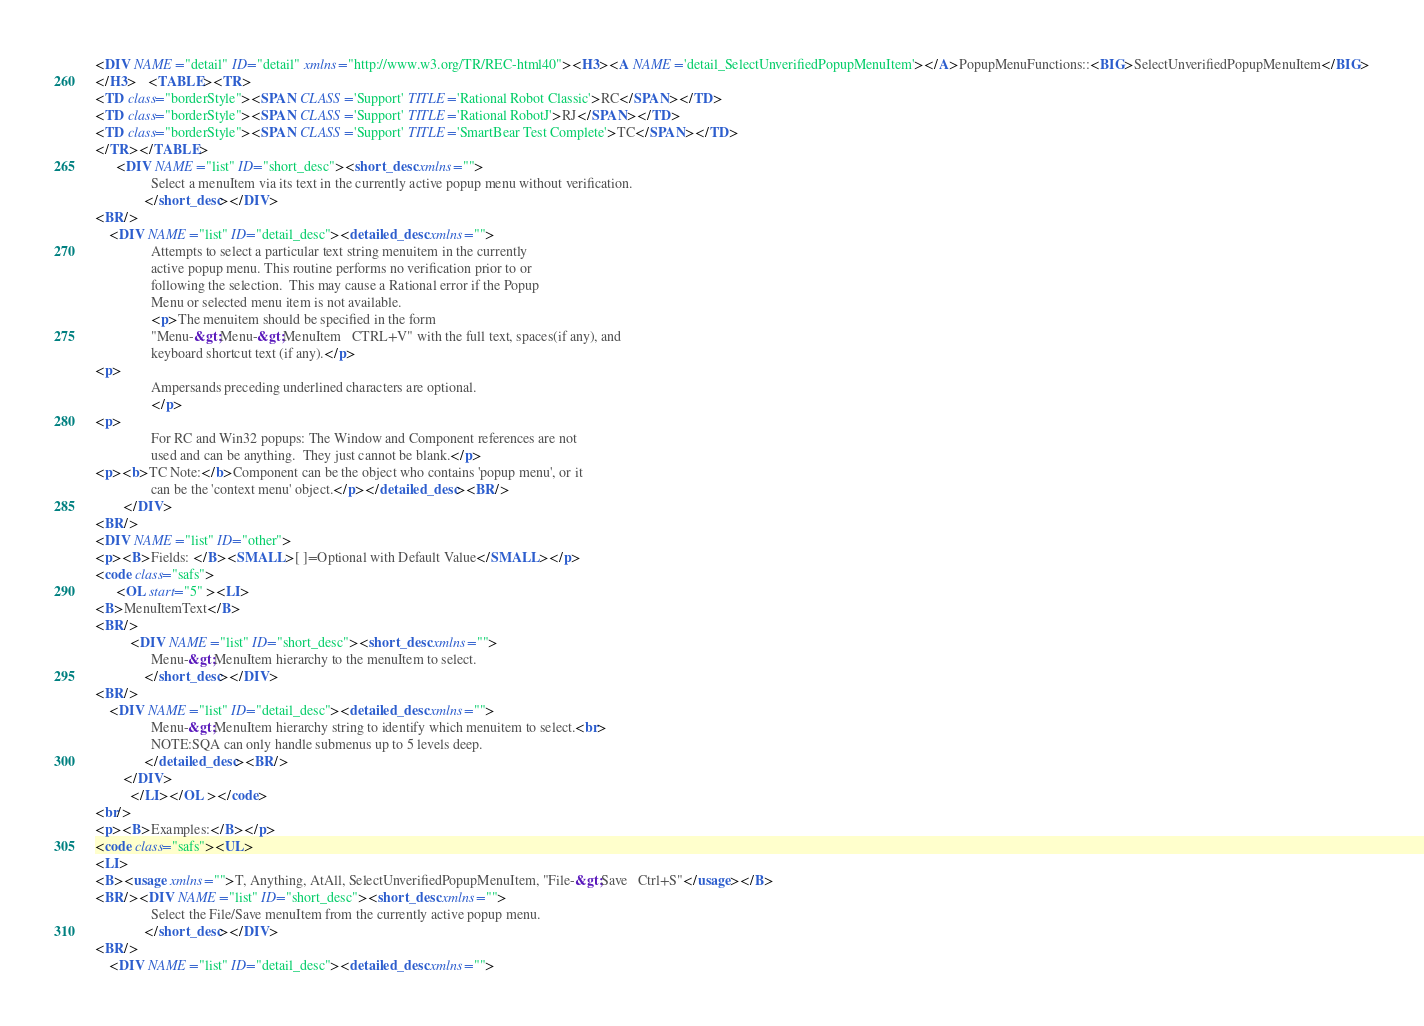<code> <loc_0><loc_0><loc_500><loc_500><_HTML_><DIV NAME="detail" ID="detail" xmlns="http://www.w3.org/TR/REC-html40"><H3><A NAME='detail_SelectUnverifiedPopupMenuItem'></A>PopupMenuFunctions::<BIG>SelectUnverifiedPopupMenuItem</BIG>
</H3>   <TABLE><TR>
<TD class="borderStyle"><SPAN CLASS='Support' TITLE='Rational Robot Classic'>RC</SPAN></TD>
<TD class="borderStyle"><SPAN CLASS='Support' TITLE='Rational RobotJ'>RJ</SPAN></TD>
<TD class="borderStyle"><SPAN CLASS='Support' TITLE='SmartBear Test Complete'>TC</SPAN></TD>
</TR></TABLE>
	  <DIV NAME="list" ID="short_desc"><short_desc xmlns=""> 
                Select a menuItem via its text in the currently active popup menu without verification.
              </short_desc></DIV>
<BR/>
	<DIV NAME="list" ID="detail_desc"><detailed_desc xmlns=""> 
                Attempts to select a particular text string menuitem in the currently 
                active popup menu. This routine performs no verification prior to or
                following the selection.  This may cause a Rational error if the Popup
                Menu or selected menu item is not available. 
                <p>The menuitem should be specified in the form 
                "Menu-&gt;Menu-&gt;MenuItem   CTRL+V" with the full text, spaces(if any), and 
                keyboard shortcut text (if any).</p>
<p>
                Ampersands preceding underlined characters are optional.
                </p>
<p>
                For RC and Win32 popups: The Window and Component references are not 
                used and can be anything.  They just cannot be blank.</p>
<p><b>TC Note:</b>Component can be the object who contains 'popup menu', or it
                can be the 'context menu' object.</p></detailed_desc><BR/>
		</DIV>
<BR/>
<DIV NAME="list" ID="other">
<p><B>Fields: </B><SMALL>[ ]=Optional with Default Value</SMALL></p>
<code class="safs">
	  <OL start="5" ><LI>
<B>MenuItemText</B>
<BR/>
		  <DIV NAME="list" ID="short_desc"><short_desc xmlns=""> 
                Menu-&gt;MenuItem hierarchy to the menuItem to select.
              </short_desc></DIV>
<BR/>
	<DIV NAME="list" ID="detail_desc"><detailed_desc xmlns=""> 
                Menu-&gt;MenuItem hierarchy string to identify which menuitem to select.<br>
                NOTE:SQA can only handle submenus up to 5 levels deep.
              </detailed_desc><BR/>
		</DIV>
		  </LI></OL ></code>
<br/>
<p><B>Examples:</B></p>
<code class="safs"><UL>
<LI>
<B><usage xmlns="">T, Anything, AtAll, SelectUnverifiedPopupMenuItem, "File-&gt;Save   Ctrl+S"</usage></B>
<BR/><DIV NAME="list" ID="short_desc"><short_desc xmlns=""> 
                Select the File/Save menuItem from the currently active popup menu.
              </short_desc></DIV>
<BR/>
	<DIV NAME="list" ID="detail_desc"><detailed_desc xmlns=""> </code> 